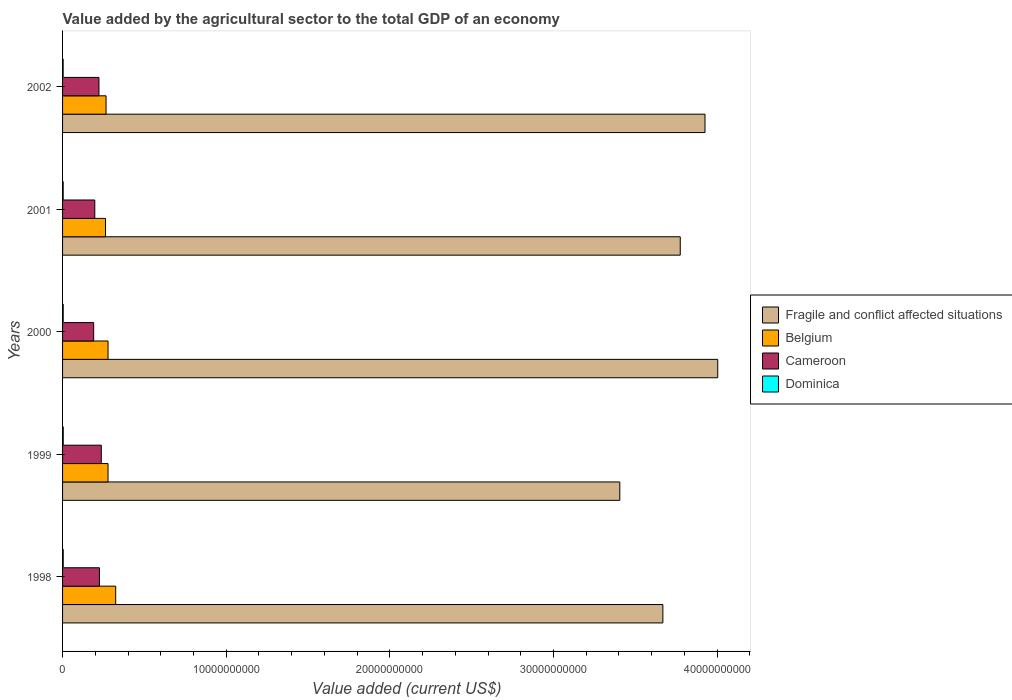How many different coloured bars are there?
Offer a very short reply. 4. How many bars are there on the 4th tick from the top?
Your response must be concise. 4. What is the label of the 2nd group of bars from the top?
Ensure brevity in your answer.  2001. In how many cases, is the number of bars for a given year not equal to the number of legend labels?
Offer a terse response. 0. What is the value added by the agricultural sector to the total GDP in Belgium in 2002?
Your answer should be compact. 2.66e+09. Across all years, what is the maximum value added by the agricultural sector to the total GDP in Belgium?
Offer a terse response. 3.25e+09. Across all years, what is the minimum value added by the agricultural sector to the total GDP in Belgium?
Give a very brief answer. 2.62e+09. In which year was the value added by the agricultural sector to the total GDP in Cameroon maximum?
Provide a short and direct response. 1999. What is the total value added by the agricultural sector to the total GDP in Fragile and conflict affected situations in the graph?
Keep it short and to the point. 1.88e+11. What is the difference between the value added by the agricultural sector to the total GDP in Fragile and conflict affected situations in 2001 and that in 2002?
Offer a very short reply. -1.51e+09. What is the difference between the value added by the agricultural sector to the total GDP in Fragile and conflict affected situations in 2000 and the value added by the agricultural sector to the total GDP in Belgium in 1999?
Provide a short and direct response. 3.73e+1. What is the average value added by the agricultural sector to the total GDP in Fragile and conflict affected situations per year?
Your answer should be compact. 3.76e+1. In the year 1999, what is the difference between the value added by the agricultural sector to the total GDP in Dominica and value added by the agricultural sector to the total GDP in Fragile and conflict affected situations?
Ensure brevity in your answer.  -3.40e+1. In how many years, is the value added by the agricultural sector to the total GDP in Dominica greater than 28000000000 US$?
Make the answer very short. 0. What is the ratio of the value added by the agricultural sector to the total GDP in Belgium in 1999 to that in 2000?
Your answer should be very brief. 1. Is the value added by the agricultural sector to the total GDP in Fragile and conflict affected situations in 2000 less than that in 2002?
Offer a terse response. No. What is the difference between the highest and the second highest value added by the agricultural sector to the total GDP in Cameroon?
Your response must be concise. 1.13e+08. What is the difference between the highest and the lowest value added by the agricultural sector to the total GDP in Fragile and conflict affected situations?
Keep it short and to the point. 5.99e+09. In how many years, is the value added by the agricultural sector to the total GDP in Dominica greater than the average value added by the agricultural sector to the total GDP in Dominica taken over all years?
Keep it short and to the point. 3. Is it the case that in every year, the sum of the value added by the agricultural sector to the total GDP in Cameroon and value added by the agricultural sector to the total GDP in Dominica is greater than the sum of value added by the agricultural sector to the total GDP in Fragile and conflict affected situations and value added by the agricultural sector to the total GDP in Belgium?
Ensure brevity in your answer.  No. What does the 2nd bar from the top in 2000 represents?
Ensure brevity in your answer.  Cameroon. What does the 1st bar from the bottom in 2002 represents?
Give a very brief answer. Fragile and conflict affected situations. Is it the case that in every year, the sum of the value added by the agricultural sector to the total GDP in Fragile and conflict affected situations and value added by the agricultural sector to the total GDP in Belgium is greater than the value added by the agricultural sector to the total GDP in Cameroon?
Ensure brevity in your answer.  Yes. What is the difference between two consecutive major ticks on the X-axis?
Provide a short and direct response. 1.00e+1. Are the values on the major ticks of X-axis written in scientific E-notation?
Your answer should be very brief. No. Where does the legend appear in the graph?
Your answer should be compact. Center right. What is the title of the graph?
Your answer should be compact. Value added by the agricultural sector to the total GDP of an economy. What is the label or title of the X-axis?
Make the answer very short. Value added (current US$). What is the Value added (current US$) of Fragile and conflict affected situations in 1998?
Keep it short and to the point. 3.67e+1. What is the Value added (current US$) in Belgium in 1998?
Ensure brevity in your answer.  3.25e+09. What is the Value added (current US$) in Cameroon in 1998?
Your response must be concise. 2.25e+09. What is the Value added (current US$) in Dominica in 1998?
Your answer should be very brief. 4.08e+07. What is the Value added (current US$) of Fragile and conflict affected situations in 1999?
Your answer should be very brief. 3.41e+1. What is the Value added (current US$) in Belgium in 1999?
Provide a succinct answer. 2.78e+09. What is the Value added (current US$) of Cameroon in 1999?
Give a very brief answer. 2.37e+09. What is the Value added (current US$) in Dominica in 1999?
Provide a short and direct response. 4.23e+07. What is the Value added (current US$) of Fragile and conflict affected situations in 2000?
Give a very brief answer. 4.00e+1. What is the Value added (current US$) of Belgium in 2000?
Your response must be concise. 2.78e+09. What is the Value added (current US$) of Cameroon in 2000?
Make the answer very short. 1.90e+09. What is the Value added (current US$) in Dominica in 2000?
Provide a short and direct response. 3.97e+07. What is the Value added (current US$) of Fragile and conflict affected situations in 2001?
Make the answer very short. 3.77e+1. What is the Value added (current US$) of Belgium in 2001?
Provide a succinct answer. 2.62e+09. What is the Value added (current US$) of Cameroon in 2001?
Provide a short and direct response. 1.97e+09. What is the Value added (current US$) in Dominica in 2001?
Offer a terse response. 3.84e+07. What is the Value added (current US$) in Fragile and conflict affected situations in 2002?
Ensure brevity in your answer.  3.93e+1. What is the Value added (current US$) in Belgium in 2002?
Your answer should be very brief. 2.66e+09. What is the Value added (current US$) in Cameroon in 2002?
Your response must be concise. 2.22e+09. What is the Value added (current US$) in Dominica in 2002?
Offer a very short reply. 3.61e+07. Across all years, what is the maximum Value added (current US$) in Fragile and conflict affected situations?
Ensure brevity in your answer.  4.00e+1. Across all years, what is the maximum Value added (current US$) of Belgium?
Offer a terse response. 3.25e+09. Across all years, what is the maximum Value added (current US$) of Cameroon?
Provide a succinct answer. 2.37e+09. Across all years, what is the maximum Value added (current US$) in Dominica?
Offer a terse response. 4.23e+07. Across all years, what is the minimum Value added (current US$) of Fragile and conflict affected situations?
Ensure brevity in your answer.  3.41e+1. Across all years, what is the minimum Value added (current US$) in Belgium?
Make the answer very short. 2.62e+09. Across all years, what is the minimum Value added (current US$) of Cameroon?
Give a very brief answer. 1.90e+09. Across all years, what is the minimum Value added (current US$) of Dominica?
Your answer should be very brief. 3.61e+07. What is the total Value added (current US$) of Fragile and conflict affected situations in the graph?
Your answer should be compact. 1.88e+11. What is the total Value added (current US$) in Belgium in the graph?
Make the answer very short. 1.41e+1. What is the total Value added (current US$) in Cameroon in the graph?
Offer a very short reply. 1.07e+1. What is the total Value added (current US$) of Dominica in the graph?
Provide a succinct answer. 1.97e+08. What is the difference between the Value added (current US$) in Fragile and conflict affected situations in 1998 and that in 1999?
Provide a short and direct response. 2.63e+09. What is the difference between the Value added (current US$) of Belgium in 1998 and that in 1999?
Provide a succinct answer. 4.69e+08. What is the difference between the Value added (current US$) of Cameroon in 1998 and that in 1999?
Provide a short and direct response. -1.13e+08. What is the difference between the Value added (current US$) of Dominica in 1998 and that in 1999?
Your response must be concise. -1.43e+06. What is the difference between the Value added (current US$) in Fragile and conflict affected situations in 1998 and that in 2000?
Give a very brief answer. -3.35e+09. What is the difference between the Value added (current US$) of Belgium in 1998 and that in 2000?
Offer a terse response. 4.69e+08. What is the difference between the Value added (current US$) of Cameroon in 1998 and that in 2000?
Ensure brevity in your answer.  3.52e+08. What is the difference between the Value added (current US$) of Dominica in 1998 and that in 2000?
Ensure brevity in your answer.  1.14e+06. What is the difference between the Value added (current US$) in Fragile and conflict affected situations in 1998 and that in 2001?
Keep it short and to the point. -1.06e+09. What is the difference between the Value added (current US$) in Belgium in 1998 and that in 2001?
Offer a terse response. 6.23e+08. What is the difference between the Value added (current US$) in Cameroon in 1998 and that in 2001?
Your answer should be compact. 2.84e+08. What is the difference between the Value added (current US$) of Dominica in 1998 and that in 2001?
Your answer should be very brief. 2.41e+06. What is the difference between the Value added (current US$) in Fragile and conflict affected situations in 1998 and that in 2002?
Make the answer very short. -2.57e+09. What is the difference between the Value added (current US$) in Belgium in 1998 and that in 2002?
Your answer should be very brief. 5.90e+08. What is the difference between the Value added (current US$) in Cameroon in 1998 and that in 2002?
Ensure brevity in your answer.  2.86e+07. What is the difference between the Value added (current US$) in Dominica in 1998 and that in 2002?
Give a very brief answer. 4.72e+06. What is the difference between the Value added (current US$) in Fragile and conflict affected situations in 1999 and that in 2000?
Offer a terse response. -5.99e+09. What is the difference between the Value added (current US$) in Belgium in 1999 and that in 2000?
Your answer should be very brief. -9.27e+04. What is the difference between the Value added (current US$) of Cameroon in 1999 and that in 2000?
Offer a very short reply. 4.66e+08. What is the difference between the Value added (current US$) of Dominica in 1999 and that in 2000?
Your response must be concise. 2.57e+06. What is the difference between the Value added (current US$) of Fragile and conflict affected situations in 1999 and that in 2001?
Your response must be concise. -3.69e+09. What is the difference between the Value added (current US$) of Belgium in 1999 and that in 2001?
Ensure brevity in your answer.  1.54e+08. What is the difference between the Value added (current US$) of Cameroon in 1999 and that in 2001?
Provide a succinct answer. 3.97e+08. What is the difference between the Value added (current US$) of Dominica in 1999 and that in 2001?
Ensure brevity in your answer.  3.84e+06. What is the difference between the Value added (current US$) in Fragile and conflict affected situations in 1999 and that in 2002?
Your answer should be compact. -5.21e+09. What is the difference between the Value added (current US$) of Belgium in 1999 and that in 2002?
Provide a succinct answer. 1.21e+08. What is the difference between the Value added (current US$) in Cameroon in 1999 and that in 2002?
Your answer should be compact. 1.42e+08. What is the difference between the Value added (current US$) of Dominica in 1999 and that in 2002?
Make the answer very short. 6.15e+06. What is the difference between the Value added (current US$) in Fragile and conflict affected situations in 2000 and that in 2001?
Offer a very short reply. 2.29e+09. What is the difference between the Value added (current US$) in Belgium in 2000 and that in 2001?
Offer a terse response. 1.54e+08. What is the difference between the Value added (current US$) in Cameroon in 2000 and that in 2001?
Provide a short and direct response. -6.85e+07. What is the difference between the Value added (current US$) in Dominica in 2000 and that in 2001?
Keep it short and to the point. 1.27e+06. What is the difference between the Value added (current US$) of Fragile and conflict affected situations in 2000 and that in 2002?
Give a very brief answer. 7.79e+08. What is the difference between the Value added (current US$) in Belgium in 2000 and that in 2002?
Your answer should be very brief. 1.21e+08. What is the difference between the Value added (current US$) in Cameroon in 2000 and that in 2002?
Provide a succinct answer. -3.24e+08. What is the difference between the Value added (current US$) in Dominica in 2000 and that in 2002?
Provide a succinct answer. 3.58e+06. What is the difference between the Value added (current US$) of Fragile and conflict affected situations in 2001 and that in 2002?
Provide a short and direct response. -1.51e+09. What is the difference between the Value added (current US$) in Belgium in 2001 and that in 2002?
Offer a very short reply. -3.30e+07. What is the difference between the Value added (current US$) in Cameroon in 2001 and that in 2002?
Give a very brief answer. -2.55e+08. What is the difference between the Value added (current US$) in Dominica in 2001 and that in 2002?
Offer a very short reply. 2.31e+06. What is the difference between the Value added (current US$) of Fragile and conflict affected situations in 1998 and the Value added (current US$) of Belgium in 1999?
Provide a succinct answer. 3.39e+1. What is the difference between the Value added (current US$) of Fragile and conflict affected situations in 1998 and the Value added (current US$) of Cameroon in 1999?
Your answer should be very brief. 3.43e+1. What is the difference between the Value added (current US$) of Fragile and conflict affected situations in 1998 and the Value added (current US$) of Dominica in 1999?
Ensure brevity in your answer.  3.66e+1. What is the difference between the Value added (current US$) of Belgium in 1998 and the Value added (current US$) of Cameroon in 1999?
Offer a terse response. 8.81e+08. What is the difference between the Value added (current US$) of Belgium in 1998 and the Value added (current US$) of Dominica in 1999?
Offer a terse response. 3.21e+09. What is the difference between the Value added (current US$) of Cameroon in 1998 and the Value added (current US$) of Dominica in 1999?
Offer a terse response. 2.21e+09. What is the difference between the Value added (current US$) in Fragile and conflict affected situations in 1998 and the Value added (current US$) in Belgium in 2000?
Make the answer very short. 3.39e+1. What is the difference between the Value added (current US$) of Fragile and conflict affected situations in 1998 and the Value added (current US$) of Cameroon in 2000?
Offer a very short reply. 3.48e+1. What is the difference between the Value added (current US$) of Fragile and conflict affected situations in 1998 and the Value added (current US$) of Dominica in 2000?
Your answer should be very brief. 3.66e+1. What is the difference between the Value added (current US$) of Belgium in 1998 and the Value added (current US$) of Cameroon in 2000?
Your response must be concise. 1.35e+09. What is the difference between the Value added (current US$) of Belgium in 1998 and the Value added (current US$) of Dominica in 2000?
Keep it short and to the point. 3.21e+09. What is the difference between the Value added (current US$) in Cameroon in 1998 and the Value added (current US$) in Dominica in 2000?
Your answer should be very brief. 2.21e+09. What is the difference between the Value added (current US$) in Fragile and conflict affected situations in 1998 and the Value added (current US$) in Belgium in 2001?
Your response must be concise. 3.41e+1. What is the difference between the Value added (current US$) of Fragile and conflict affected situations in 1998 and the Value added (current US$) of Cameroon in 2001?
Provide a succinct answer. 3.47e+1. What is the difference between the Value added (current US$) of Fragile and conflict affected situations in 1998 and the Value added (current US$) of Dominica in 2001?
Your answer should be compact. 3.66e+1. What is the difference between the Value added (current US$) of Belgium in 1998 and the Value added (current US$) of Cameroon in 2001?
Ensure brevity in your answer.  1.28e+09. What is the difference between the Value added (current US$) in Belgium in 1998 and the Value added (current US$) in Dominica in 2001?
Offer a very short reply. 3.21e+09. What is the difference between the Value added (current US$) in Cameroon in 1998 and the Value added (current US$) in Dominica in 2001?
Make the answer very short. 2.21e+09. What is the difference between the Value added (current US$) of Fragile and conflict affected situations in 1998 and the Value added (current US$) of Belgium in 2002?
Keep it short and to the point. 3.40e+1. What is the difference between the Value added (current US$) in Fragile and conflict affected situations in 1998 and the Value added (current US$) in Cameroon in 2002?
Your answer should be compact. 3.45e+1. What is the difference between the Value added (current US$) of Fragile and conflict affected situations in 1998 and the Value added (current US$) of Dominica in 2002?
Ensure brevity in your answer.  3.66e+1. What is the difference between the Value added (current US$) of Belgium in 1998 and the Value added (current US$) of Cameroon in 2002?
Keep it short and to the point. 1.02e+09. What is the difference between the Value added (current US$) of Belgium in 1998 and the Value added (current US$) of Dominica in 2002?
Offer a terse response. 3.21e+09. What is the difference between the Value added (current US$) in Cameroon in 1998 and the Value added (current US$) in Dominica in 2002?
Your answer should be very brief. 2.22e+09. What is the difference between the Value added (current US$) of Fragile and conflict affected situations in 1999 and the Value added (current US$) of Belgium in 2000?
Ensure brevity in your answer.  3.13e+1. What is the difference between the Value added (current US$) in Fragile and conflict affected situations in 1999 and the Value added (current US$) in Cameroon in 2000?
Your answer should be compact. 3.21e+1. What is the difference between the Value added (current US$) in Fragile and conflict affected situations in 1999 and the Value added (current US$) in Dominica in 2000?
Keep it short and to the point. 3.40e+1. What is the difference between the Value added (current US$) in Belgium in 1999 and the Value added (current US$) in Cameroon in 2000?
Offer a terse response. 8.78e+08. What is the difference between the Value added (current US$) of Belgium in 1999 and the Value added (current US$) of Dominica in 2000?
Your response must be concise. 2.74e+09. What is the difference between the Value added (current US$) of Cameroon in 1999 and the Value added (current US$) of Dominica in 2000?
Ensure brevity in your answer.  2.33e+09. What is the difference between the Value added (current US$) in Fragile and conflict affected situations in 1999 and the Value added (current US$) in Belgium in 2001?
Your answer should be compact. 3.14e+1. What is the difference between the Value added (current US$) in Fragile and conflict affected situations in 1999 and the Value added (current US$) in Cameroon in 2001?
Give a very brief answer. 3.21e+1. What is the difference between the Value added (current US$) in Fragile and conflict affected situations in 1999 and the Value added (current US$) in Dominica in 2001?
Offer a terse response. 3.40e+1. What is the difference between the Value added (current US$) in Belgium in 1999 and the Value added (current US$) in Cameroon in 2001?
Offer a very short reply. 8.09e+08. What is the difference between the Value added (current US$) of Belgium in 1999 and the Value added (current US$) of Dominica in 2001?
Your answer should be very brief. 2.74e+09. What is the difference between the Value added (current US$) in Cameroon in 1999 and the Value added (current US$) in Dominica in 2001?
Make the answer very short. 2.33e+09. What is the difference between the Value added (current US$) of Fragile and conflict affected situations in 1999 and the Value added (current US$) of Belgium in 2002?
Your response must be concise. 3.14e+1. What is the difference between the Value added (current US$) of Fragile and conflict affected situations in 1999 and the Value added (current US$) of Cameroon in 2002?
Your response must be concise. 3.18e+1. What is the difference between the Value added (current US$) in Fragile and conflict affected situations in 1999 and the Value added (current US$) in Dominica in 2002?
Keep it short and to the point. 3.40e+1. What is the difference between the Value added (current US$) in Belgium in 1999 and the Value added (current US$) in Cameroon in 2002?
Offer a very short reply. 5.54e+08. What is the difference between the Value added (current US$) of Belgium in 1999 and the Value added (current US$) of Dominica in 2002?
Your response must be concise. 2.74e+09. What is the difference between the Value added (current US$) of Cameroon in 1999 and the Value added (current US$) of Dominica in 2002?
Provide a succinct answer. 2.33e+09. What is the difference between the Value added (current US$) of Fragile and conflict affected situations in 2000 and the Value added (current US$) of Belgium in 2001?
Provide a short and direct response. 3.74e+1. What is the difference between the Value added (current US$) of Fragile and conflict affected situations in 2000 and the Value added (current US$) of Cameroon in 2001?
Provide a succinct answer. 3.81e+1. What is the difference between the Value added (current US$) in Fragile and conflict affected situations in 2000 and the Value added (current US$) in Dominica in 2001?
Your answer should be very brief. 4.00e+1. What is the difference between the Value added (current US$) of Belgium in 2000 and the Value added (current US$) of Cameroon in 2001?
Your answer should be compact. 8.09e+08. What is the difference between the Value added (current US$) of Belgium in 2000 and the Value added (current US$) of Dominica in 2001?
Give a very brief answer. 2.74e+09. What is the difference between the Value added (current US$) in Cameroon in 2000 and the Value added (current US$) in Dominica in 2001?
Your response must be concise. 1.86e+09. What is the difference between the Value added (current US$) of Fragile and conflict affected situations in 2000 and the Value added (current US$) of Belgium in 2002?
Provide a succinct answer. 3.74e+1. What is the difference between the Value added (current US$) in Fragile and conflict affected situations in 2000 and the Value added (current US$) in Cameroon in 2002?
Your response must be concise. 3.78e+1. What is the difference between the Value added (current US$) of Fragile and conflict affected situations in 2000 and the Value added (current US$) of Dominica in 2002?
Your response must be concise. 4.00e+1. What is the difference between the Value added (current US$) in Belgium in 2000 and the Value added (current US$) in Cameroon in 2002?
Offer a very short reply. 5.54e+08. What is the difference between the Value added (current US$) in Belgium in 2000 and the Value added (current US$) in Dominica in 2002?
Keep it short and to the point. 2.74e+09. What is the difference between the Value added (current US$) of Cameroon in 2000 and the Value added (current US$) of Dominica in 2002?
Offer a very short reply. 1.86e+09. What is the difference between the Value added (current US$) of Fragile and conflict affected situations in 2001 and the Value added (current US$) of Belgium in 2002?
Provide a short and direct response. 3.51e+1. What is the difference between the Value added (current US$) of Fragile and conflict affected situations in 2001 and the Value added (current US$) of Cameroon in 2002?
Ensure brevity in your answer.  3.55e+1. What is the difference between the Value added (current US$) in Fragile and conflict affected situations in 2001 and the Value added (current US$) in Dominica in 2002?
Give a very brief answer. 3.77e+1. What is the difference between the Value added (current US$) in Belgium in 2001 and the Value added (current US$) in Cameroon in 2002?
Ensure brevity in your answer.  4.00e+08. What is the difference between the Value added (current US$) in Belgium in 2001 and the Value added (current US$) in Dominica in 2002?
Offer a very short reply. 2.59e+09. What is the difference between the Value added (current US$) in Cameroon in 2001 and the Value added (current US$) in Dominica in 2002?
Your response must be concise. 1.93e+09. What is the average Value added (current US$) in Fragile and conflict affected situations per year?
Your answer should be very brief. 3.76e+1. What is the average Value added (current US$) of Belgium per year?
Your response must be concise. 2.82e+09. What is the average Value added (current US$) in Cameroon per year?
Your answer should be very brief. 2.14e+09. What is the average Value added (current US$) in Dominica per year?
Offer a terse response. 3.95e+07. In the year 1998, what is the difference between the Value added (current US$) of Fragile and conflict affected situations and Value added (current US$) of Belgium?
Your answer should be very brief. 3.34e+1. In the year 1998, what is the difference between the Value added (current US$) in Fragile and conflict affected situations and Value added (current US$) in Cameroon?
Offer a terse response. 3.44e+1. In the year 1998, what is the difference between the Value added (current US$) in Fragile and conflict affected situations and Value added (current US$) in Dominica?
Your answer should be compact. 3.66e+1. In the year 1998, what is the difference between the Value added (current US$) of Belgium and Value added (current US$) of Cameroon?
Offer a terse response. 9.94e+08. In the year 1998, what is the difference between the Value added (current US$) of Belgium and Value added (current US$) of Dominica?
Your answer should be very brief. 3.21e+09. In the year 1998, what is the difference between the Value added (current US$) in Cameroon and Value added (current US$) in Dominica?
Ensure brevity in your answer.  2.21e+09. In the year 1999, what is the difference between the Value added (current US$) in Fragile and conflict affected situations and Value added (current US$) in Belgium?
Offer a very short reply. 3.13e+1. In the year 1999, what is the difference between the Value added (current US$) of Fragile and conflict affected situations and Value added (current US$) of Cameroon?
Offer a terse response. 3.17e+1. In the year 1999, what is the difference between the Value added (current US$) in Fragile and conflict affected situations and Value added (current US$) in Dominica?
Give a very brief answer. 3.40e+1. In the year 1999, what is the difference between the Value added (current US$) in Belgium and Value added (current US$) in Cameroon?
Your answer should be very brief. 4.12e+08. In the year 1999, what is the difference between the Value added (current US$) of Belgium and Value added (current US$) of Dominica?
Give a very brief answer. 2.74e+09. In the year 1999, what is the difference between the Value added (current US$) of Cameroon and Value added (current US$) of Dominica?
Offer a terse response. 2.32e+09. In the year 2000, what is the difference between the Value added (current US$) in Fragile and conflict affected situations and Value added (current US$) in Belgium?
Provide a short and direct response. 3.73e+1. In the year 2000, what is the difference between the Value added (current US$) of Fragile and conflict affected situations and Value added (current US$) of Cameroon?
Provide a short and direct response. 3.81e+1. In the year 2000, what is the difference between the Value added (current US$) in Fragile and conflict affected situations and Value added (current US$) in Dominica?
Offer a very short reply. 4.00e+1. In the year 2000, what is the difference between the Value added (current US$) of Belgium and Value added (current US$) of Cameroon?
Your answer should be very brief. 8.78e+08. In the year 2000, what is the difference between the Value added (current US$) of Belgium and Value added (current US$) of Dominica?
Ensure brevity in your answer.  2.74e+09. In the year 2000, what is the difference between the Value added (current US$) in Cameroon and Value added (current US$) in Dominica?
Keep it short and to the point. 1.86e+09. In the year 2001, what is the difference between the Value added (current US$) in Fragile and conflict affected situations and Value added (current US$) in Belgium?
Your answer should be compact. 3.51e+1. In the year 2001, what is the difference between the Value added (current US$) in Fragile and conflict affected situations and Value added (current US$) in Cameroon?
Offer a terse response. 3.58e+1. In the year 2001, what is the difference between the Value added (current US$) in Fragile and conflict affected situations and Value added (current US$) in Dominica?
Your answer should be compact. 3.77e+1. In the year 2001, what is the difference between the Value added (current US$) in Belgium and Value added (current US$) in Cameroon?
Provide a succinct answer. 6.55e+08. In the year 2001, what is the difference between the Value added (current US$) in Belgium and Value added (current US$) in Dominica?
Provide a succinct answer. 2.59e+09. In the year 2001, what is the difference between the Value added (current US$) in Cameroon and Value added (current US$) in Dominica?
Make the answer very short. 1.93e+09. In the year 2002, what is the difference between the Value added (current US$) in Fragile and conflict affected situations and Value added (current US$) in Belgium?
Your answer should be very brief. 3.66e+1. In the year 2002, what is the difference between the Value added (current US$) in Fragile and conflict affected situations and Value added (current US$) in Cameroon?
Make the answer very short. 3.70e+1. In the year 2002, what is the difference between the Value added (current US$) in Fragile and conflict affected situations and Value added (current US$) in Dominica?
Keep it short and to the point. 3.92e+1. In the year 2002, what is the difference between the Value added (current US$) in Belgium and Value added (current US$) in Cameroon?
Keep it short and to the point. 4.33e+08. In the year 2002, what is the difference between the Value added (current US$) in Belgium and Value added (current US$) in Dominica?
Offer a terse response. 2.62e+09. In the year 2002, what is the difference between the Value added (current US$) in Cameroon and Value added (current US$) in Dominica?
Offer a terse response. 2.19e+09. What is the ratio of the Value added (current US$) in Fragile and conflict affected situations in 1998 to that in 1999?
Your answer should be compact. 1.08. What is the ratio of the Value added (current US$) in Belgium in 1998 to that in 1999?
Offer a terse response. 1.17. What is the ratio of the Value added (current US$) of Cameroon in 1998 to that in 1999?
Your answer should be compact. 0.95. What is the ratio of the Value added (current US$) in Dominica in 1998 to that in 1999?
Provide a short and direct response. 0.97. What is the ratio of the Value added (current US$) in Fragile and conflict affected situations in 1998 to that in 2000?
Give a very brief answer. 0.92. What is the ratio of the Value added (current US$) of Belgium in 1998 to that in 2000?
Provide a succinct answer. 1.17. What is the ratio of the Value added (current US$) in Cameroon in 1998 to that in 2000?
Offer a terse response. 1.19. What is the ratio of the Value added (current US$) in Dominica in 1998 to that in 2000?
Provide a short and direct response. 1.03. What is the ratio of the Value added (current US$) in Fragile and conflict affected situations in 1998 to that in 2001?
Offer a very short reply. 0.97. What is the ratio of the Value added (current US$) in Belgium in 1998 to that in 2001?
Your answer should be very brief. 1.24. What is the ratio of the Value added (current US$) in Cameroon in 1998 to that in 2001?
Your response must be concise. 1.14. What is the ratio of the Value added (current US$) in Dominica in 1998 to that in 2001?
Provide a short and direct response. 1.06. What is the ratio of the Value added (current US$) of Fragile and conflict affected situations in 1998 to that in 2002?
Your answer should be very brief. 0.93. What is the ratio of the Value added (current US$) of Belgium in 1998 to that in 2002?
Your answer should be very brief. 1.22. What is the ratio of the Value added (current US$) in Cameroon in 1998 to that in 2002?
Offer a very short reply. 1.01. What is the ratio of the Value added (current US$) in Dominica in 1998 to that in 2002?
Keep it short and to the point. 1.13. What is the ratio of the Value added (current US$) of Fragile and conflict affected situations in 1999 to that in 2000?
Offer a very short reply. 0.85. What is the ratio of the Value added (current US$) in Cameroon in 1999 to that in 2000?
Offer a very short reply. 1.25. What is the ratio of the Value added (current US$) in Dominica in 1999 to that in 2000?
Give a very brief answer. 1.06. What is the ratio of the Value added (current US$) in Fragile and conflict affected situations in 1999 to that in 2001?
Ensure brevity in your answer.  0.9. What is the ratio of the Value added (current US$) of Belgium in 1999 to that in 2001?
Provide a succinct answer. 1.06. What is the ratio of the Value added (current US$) in Cameroon in 1999 to that in 2001?
Your answer should be compact. 1.2. What is the ratio of the Value added (current US$) in Dominica in 1999 to that in 2001?
Your response must be concise. 1.1. What is the ratio of the Value added (current US$) in Fragile and conflict affected situations in 1999 to that in 2002?
Ensure brevity in your answer.  0.87. What is the ratio of the Value added (current US$) in Belgium in 1999 to that in 2002?
Keep it short and to the point. 1.05. What is the ratio of the Value added (current US$) of Cameroon in 1999 to that in 2002?
Provide a succinct answer. 1.06. What is the ratio of the Value added (current US$) in Dominica in 1999 to that in 2002?
Offer a very short reply. 1.17. What is the ratio of the Value added (current US$) in Fragile and conflict affected situations in 2000 to that in 2001?
Give a very brief answer. 1.06. What is the ratio of the Value added (current US$) in Belgium in 2000 to that in 2001?
Your answer should be very brief. 1.06. What is the ratio of the Value added (current US$) in Cameroon in 2000 to that in 2001?
Your answer should be very brief. 0.97. What is the ratio of the Value added (current US$) in Dominica in 2000 to that in 2001?
Offer a terse response. 1.03. What is the ratio of the Value added (current US$) of Fragile and conflict affected situations in 2000 to that in 2002?
Keep it short and to the point. 1.02. What is the ratio of the Value added (current US$) of Belgium in 2000 to that in 2002?
Keep it short and to the point. 1.05. What is the ratio of the Value added (current US$) of Cameroon in 2000 to that in 2002?
Your answer should be very brief. 0.85. What is the ratio of the Value added (current US$) of Dominica in 2000 to that in 2002?
Offer a terse response. 1.1. What is the ratio of the Value added (current US$) of Fragile and conflict affected situations in 2001 to that in 2002?
Ensure brevity in your answer.  0.96. What is the ratio of the Value added (current US$) in Belgium in 2001 to that in 2002?
Offer a terse response. 0.99. What is the ratio of the Value added (current US$) of Cameroon in 2001 to that in 2002?
Offer a very short reply. 0.89. What is the ratio of the Value added (current US$) in Dominica in 2001 to that in 2002?
Provide a succinct answer. 1.06. What is the difference between the highest and the second highest Value added (current US$) in Fragile and conflict affected situations?
Offer a terse response. 7.79e+08. What is the difference between the highest and the second highest Value added (current US$) in Belgium?
Give a very brief answer. 4.69e+08. What is the difference between the highest and the second highest Value added (current US$) of Cameroon?
Provide a short and direct response. 1.13e+08. What is the difference between the highest and the second highest Value added (current US$) of Dominica?
Ensure brevity in your answer.  1.43e+06. What is the difference between the highest and the lowest Value added (current US$) of Fragile and conflict affected situations?
Offer a terse response. 5.99e+09. What is the difference between the highest and the lowest Value added (current US$) of Belgium?
Provide a short and direct response. 6.23e+08. What is the difference between the highest and the lowest Value added (current US$) in Cameroon?
Your answer should be very brief. 4.66e+08. What is the difference between the highest and the lowest Value added (current US$) of Dominica?
Offer a very short reply. 6.15e+06. 